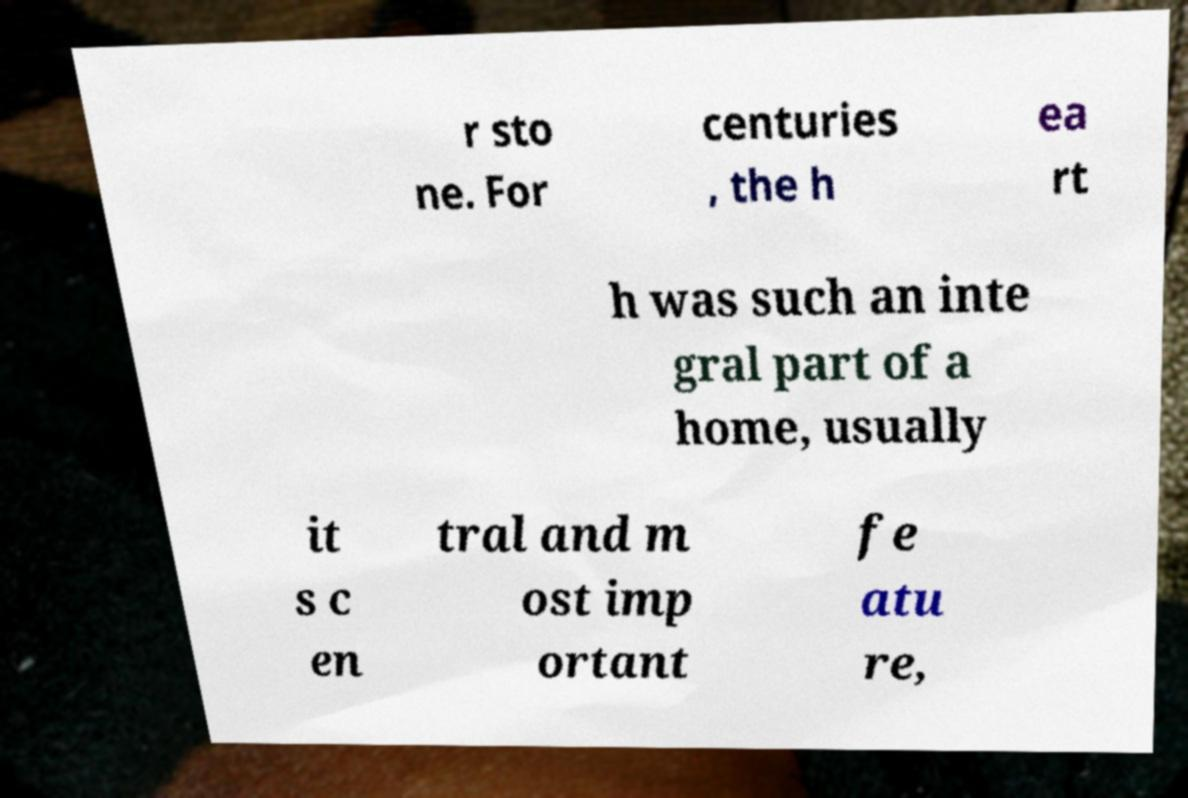Please read and relay the text visible in this image. What does it say? r sto ne. For centuries , the h ea rt h was such an inte gral part of a home, usually it s c en tral and m ost imp ortant fe atu re, 